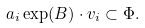Convert formula to latex. <formula><loc_0><loc_0><loc_500><loc_500>a _ { i } \exp ( B ) \cdot v _ { i } \subset \Phi .</formula> 